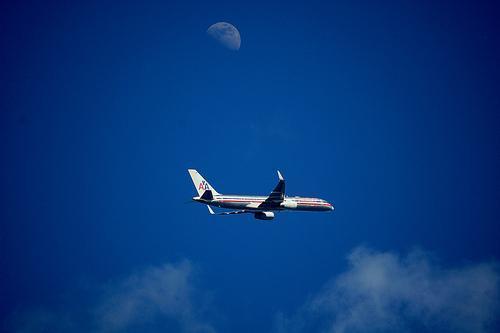How many planes are in the picture?
Give a very brief answer. 1. 